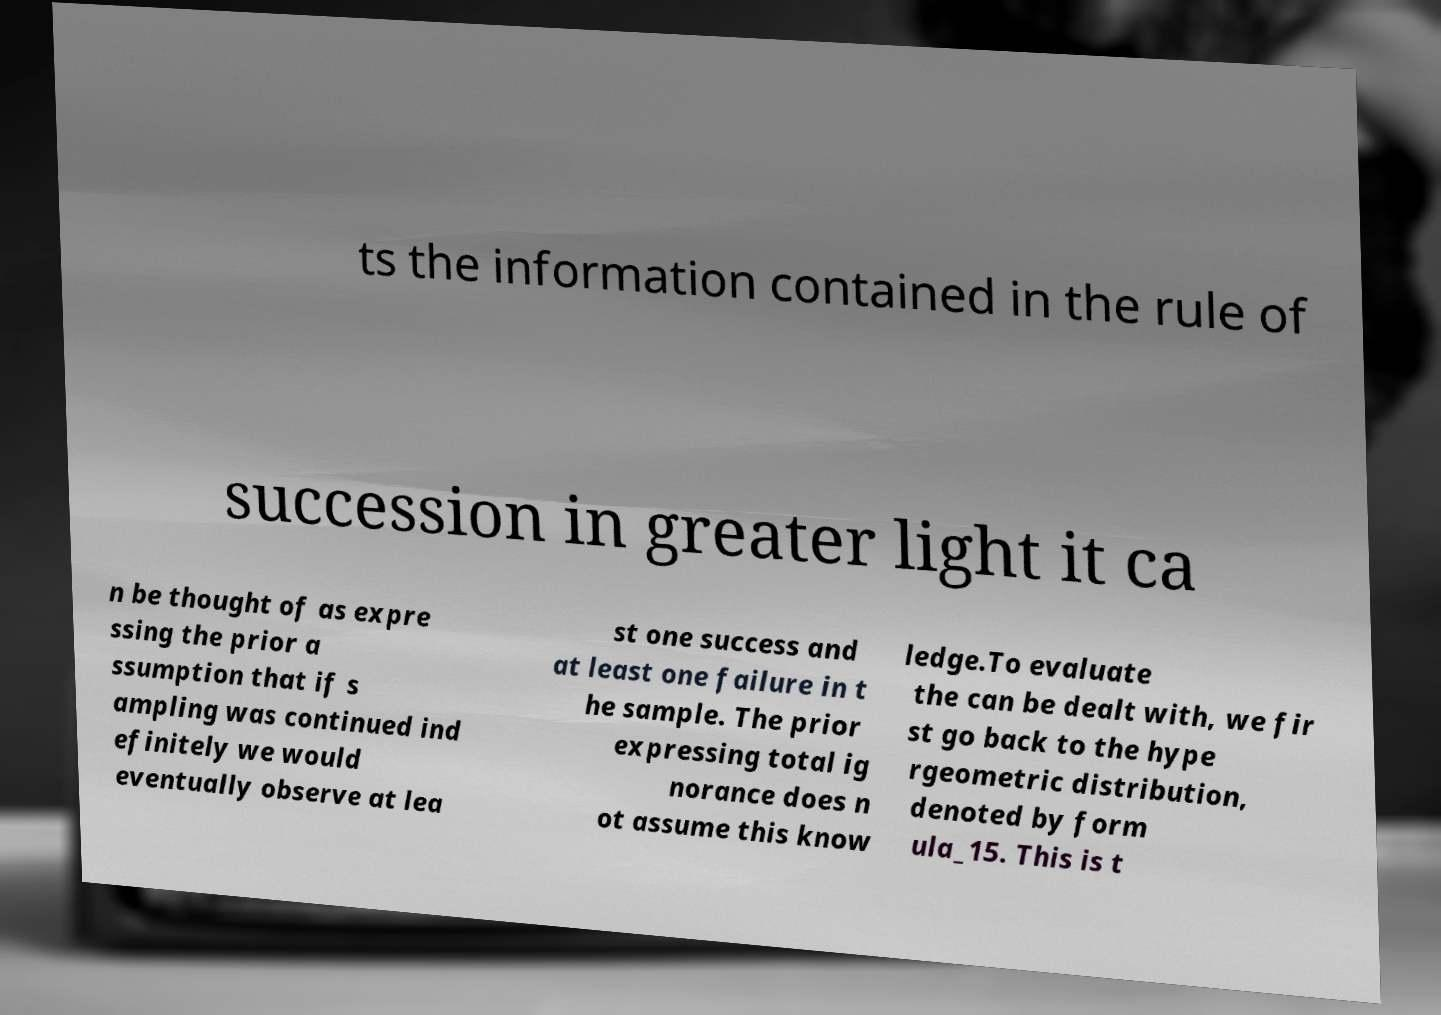Please identify and transcribe the text found in this image. ts the information contained in the rule of succession in greater light it ca n be thought of as expre ssing the prior a ssumption that if s ampling was continued ind efinitely we would eventually observe at lea st one success and at least one failure in t he sample. The prior expressing total ig norance does n ot assume this know ledge.To evaluate the can be dealt with, we fir st go back to the hype rgeometric distribution, denoted by form ula_15. This is t 